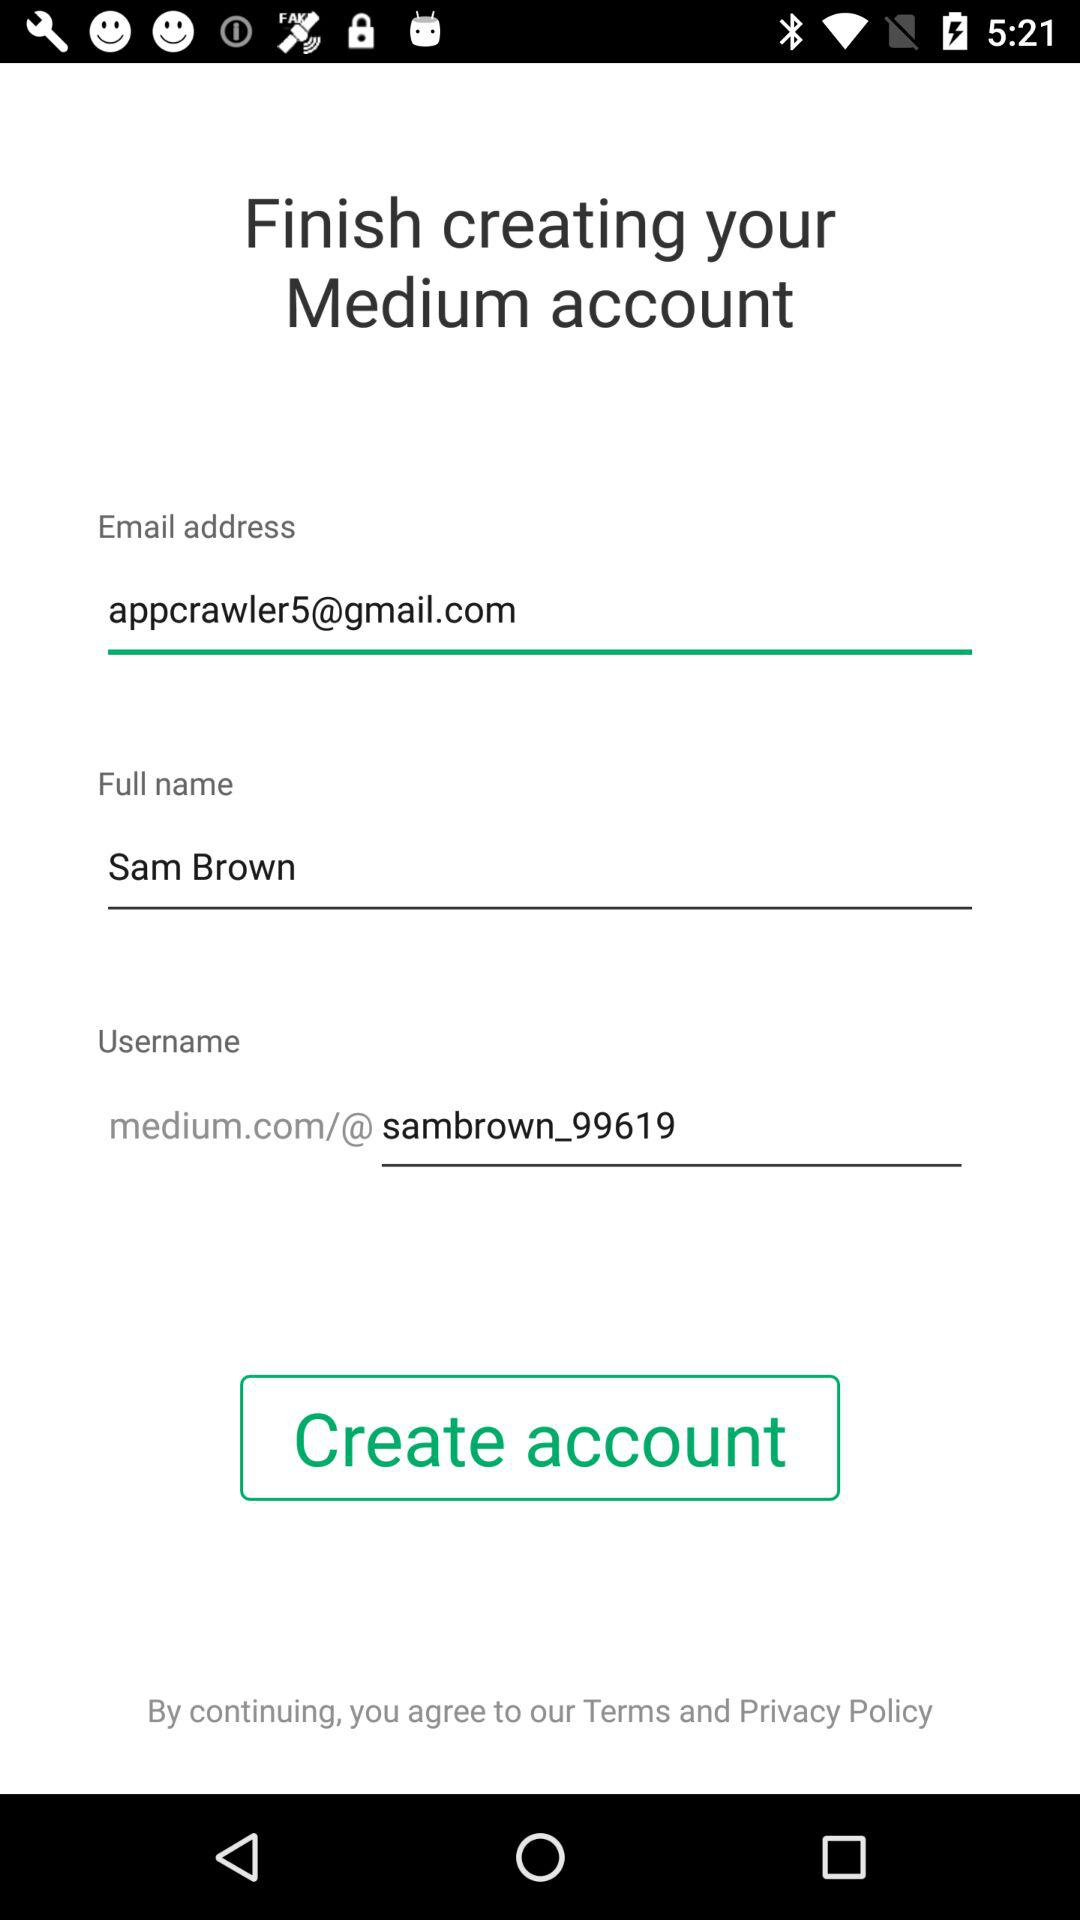How many inputs are there in the form?
Answer the question using a single word or phrase. 3 